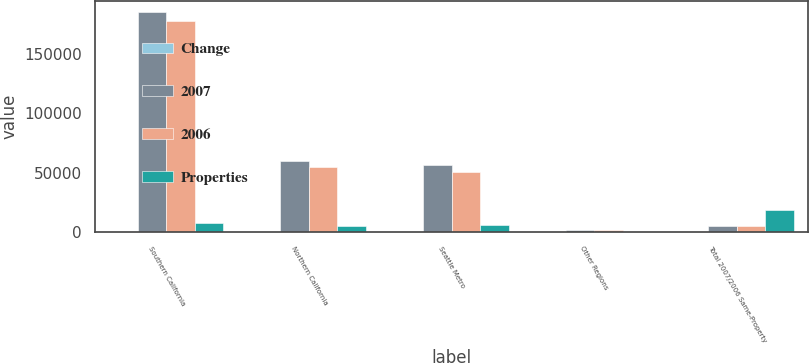Convert chart to OTSL. <chart><loc_0><loc_0><loc_500><loc_500><stacked_bar_chart><ecel><fcel>Southern California<fcel>Northern California<fcel>Seattle Metro<fcel>Other Regions<fcel>Total 2007/2006 Same-Property<nl><fcel>Change<fcel>56<fcel>16<fcel>22<fcel>1<fcel>95<nl><fcel>2007<fcel>185060<fcel>60024<fcel>56427<fcel>2015<fcel>5356<nl><fcel>2006<fcel>177336<fcel>54887<fcel>50852<fcel>1980<fcel>5356<nl><fcel>Properties<fcel>7724<fcel>5137<fcel>5575<fcel>35<fcel>18471<nl></chart> 